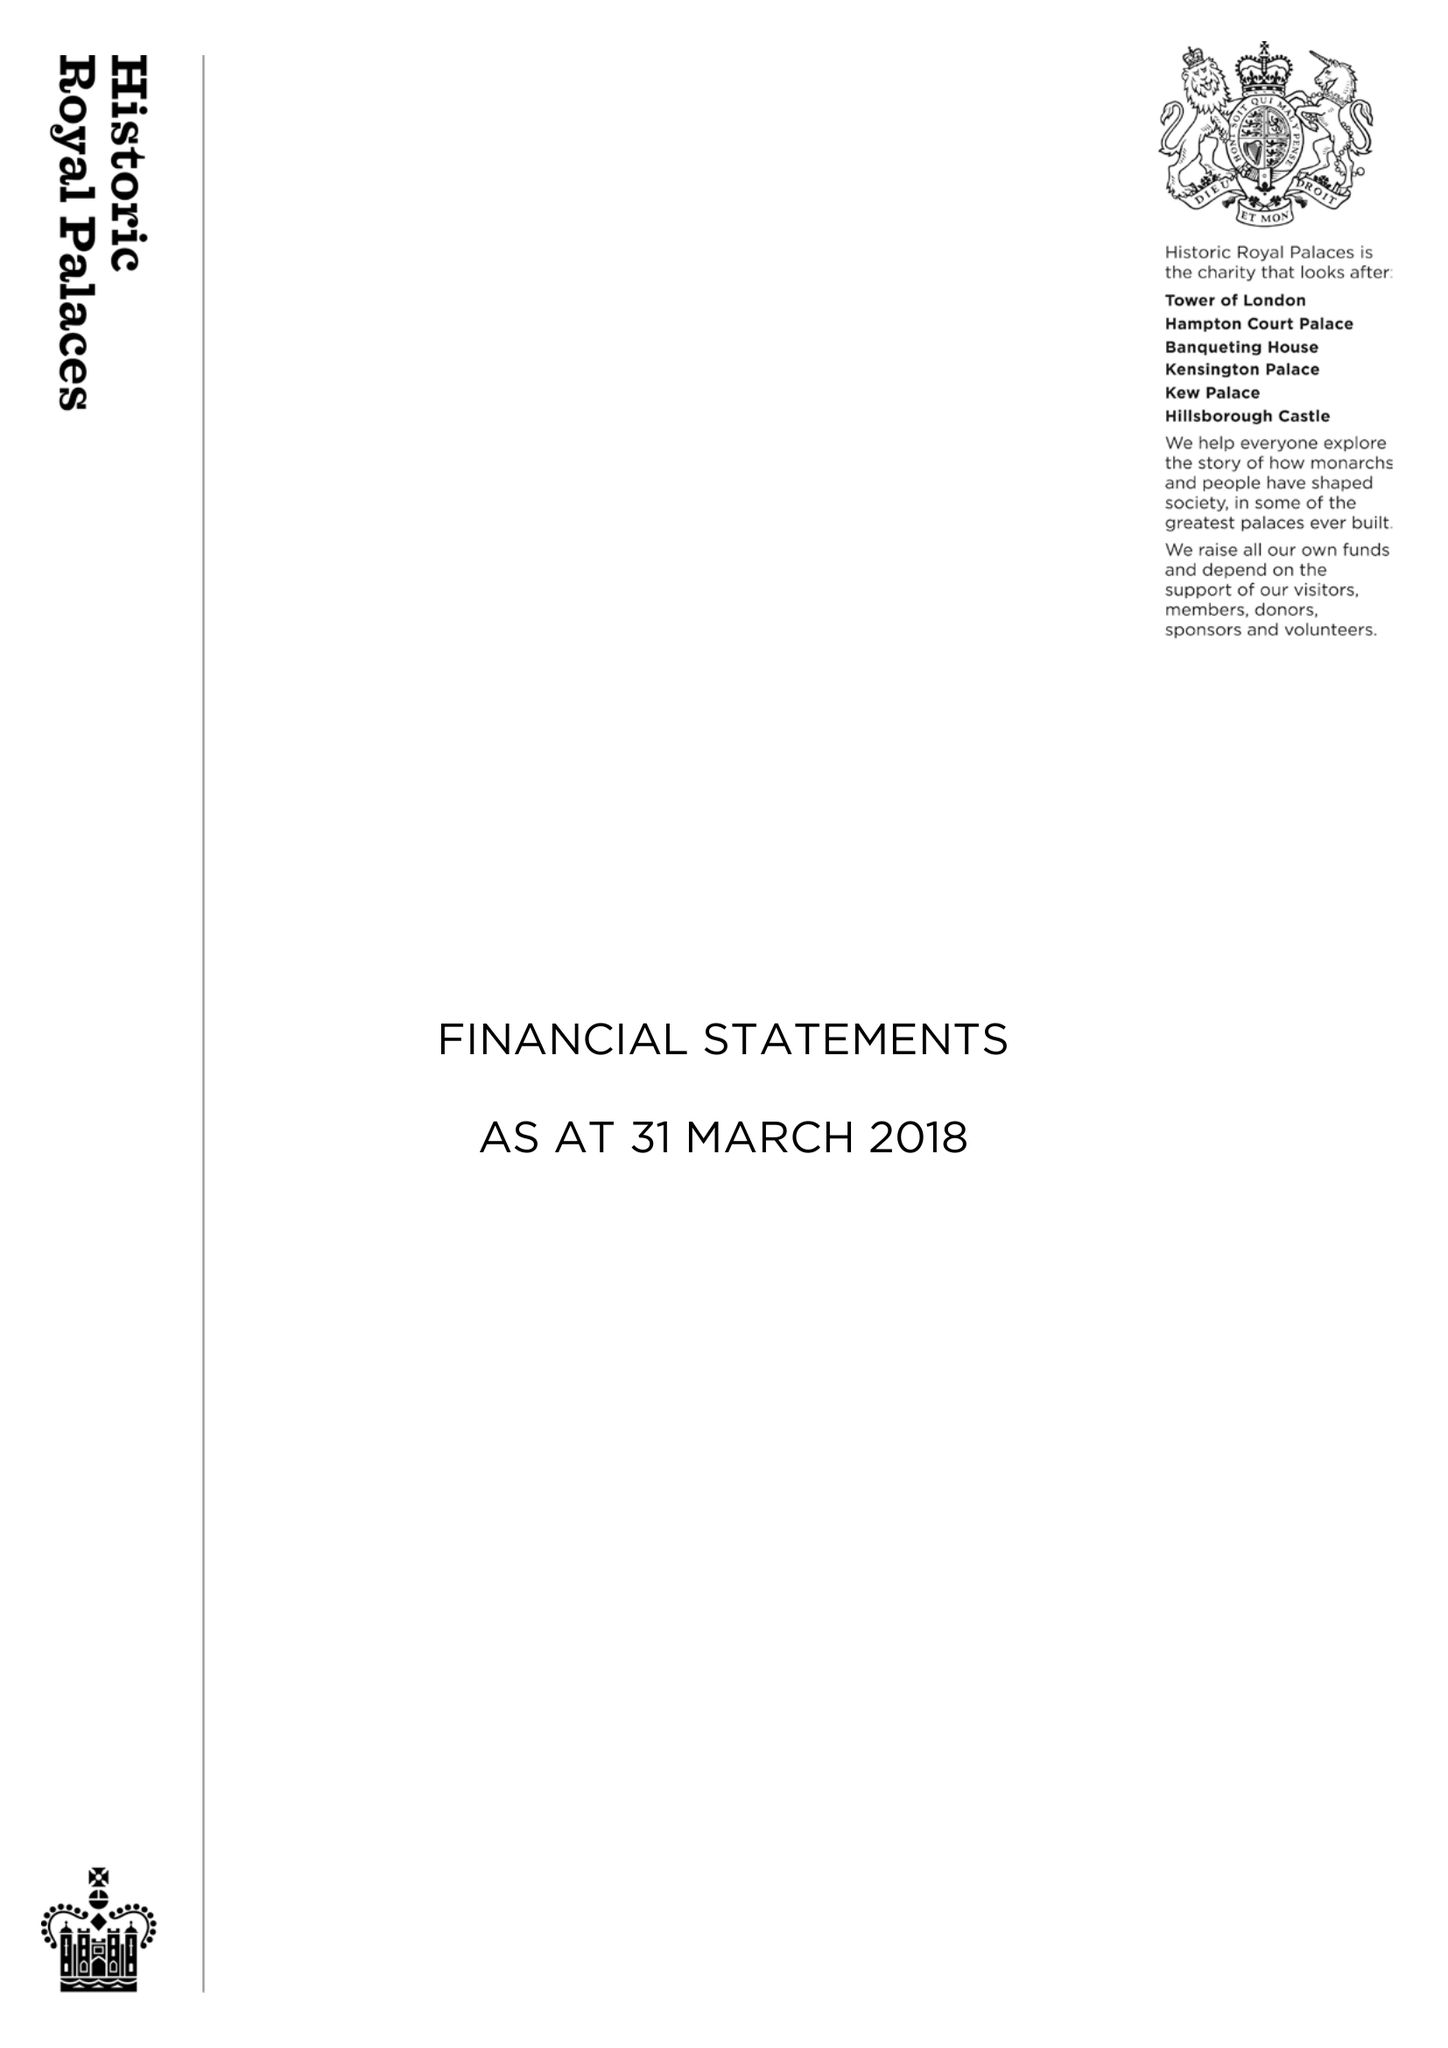What is the value for the income_annually_in_british_pounds?
Answer the question using a single word or phrase. 98186349.00 